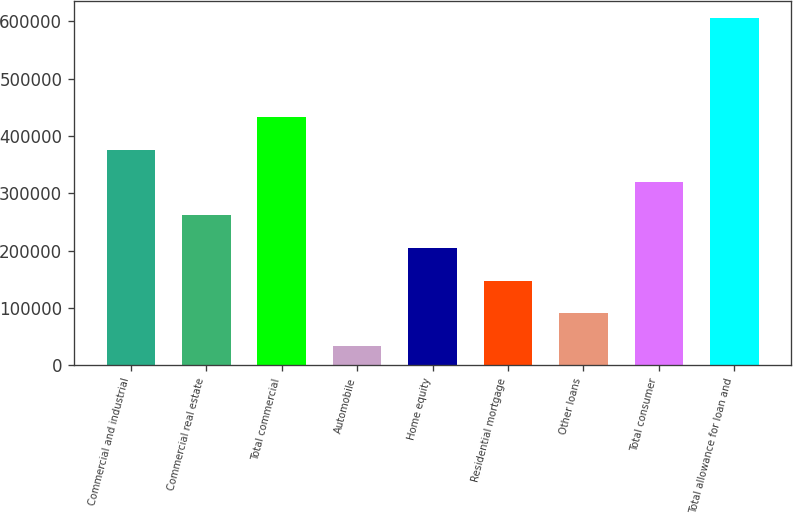Convert chart to OTSL. <chart><loc_0><loc_0><loc_500><loc_500><bar_chart><fcel>Commercial and industrial<fcel>Commercial real estate<fcel>Total commercial<fcel>Automobile<fcel>Home equity<fcel>Residential mortgage<fcel>Other loans<fcel>Total consumer<fcel>Total allowance for loan and<nl><fcel>376504<fcel>262158<fcel>433677<fcel>33466<fcel>204985<fcel>147812<fcel>90639<fcel>319331<fcel>605196<nl></chart> 